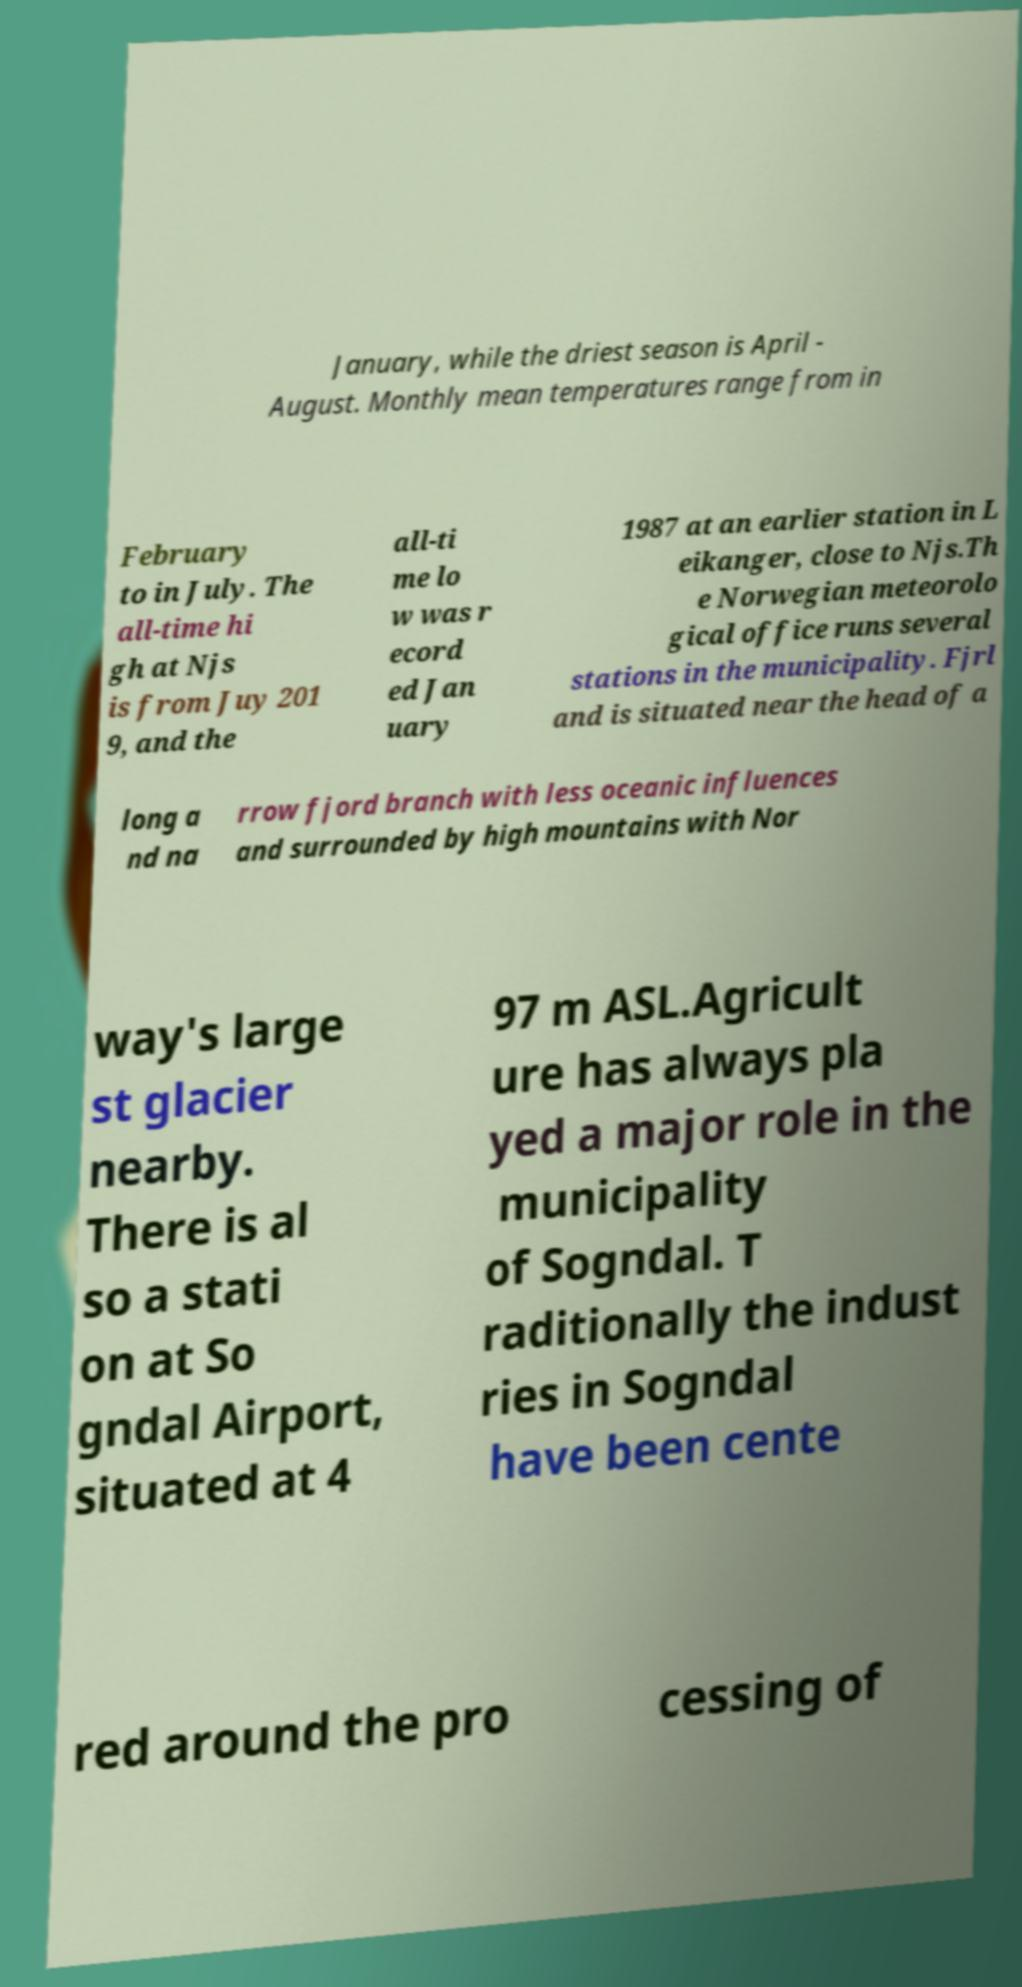Please read and relay the text visible in this image. What does it say? January, while the driest season is April - August. Monthly mean temperatures range from in February to in July. The all-time hi gh at Njs is from Juy 201 9, and the all-ti me lo w was r ecord ed Jan uary 1987 at an earlier station in L eikanger, close to Njs.Th e Norwegian meteorolo gical office runs several stations in the municipality. Fjrl and is situated near the head of a long a nd na rrow fjord branch with less oceanic influences and surrounded by high mountains with Nor way's large st glacier nearby. There is al so a stati on at So gndal Airport, situated at 4 97 m ASL.Agricult ure has always pla yed a major role in the municipality of Sogndal. T raditionally the indust ries in Sogndal have been cente red around the pro cessing of 